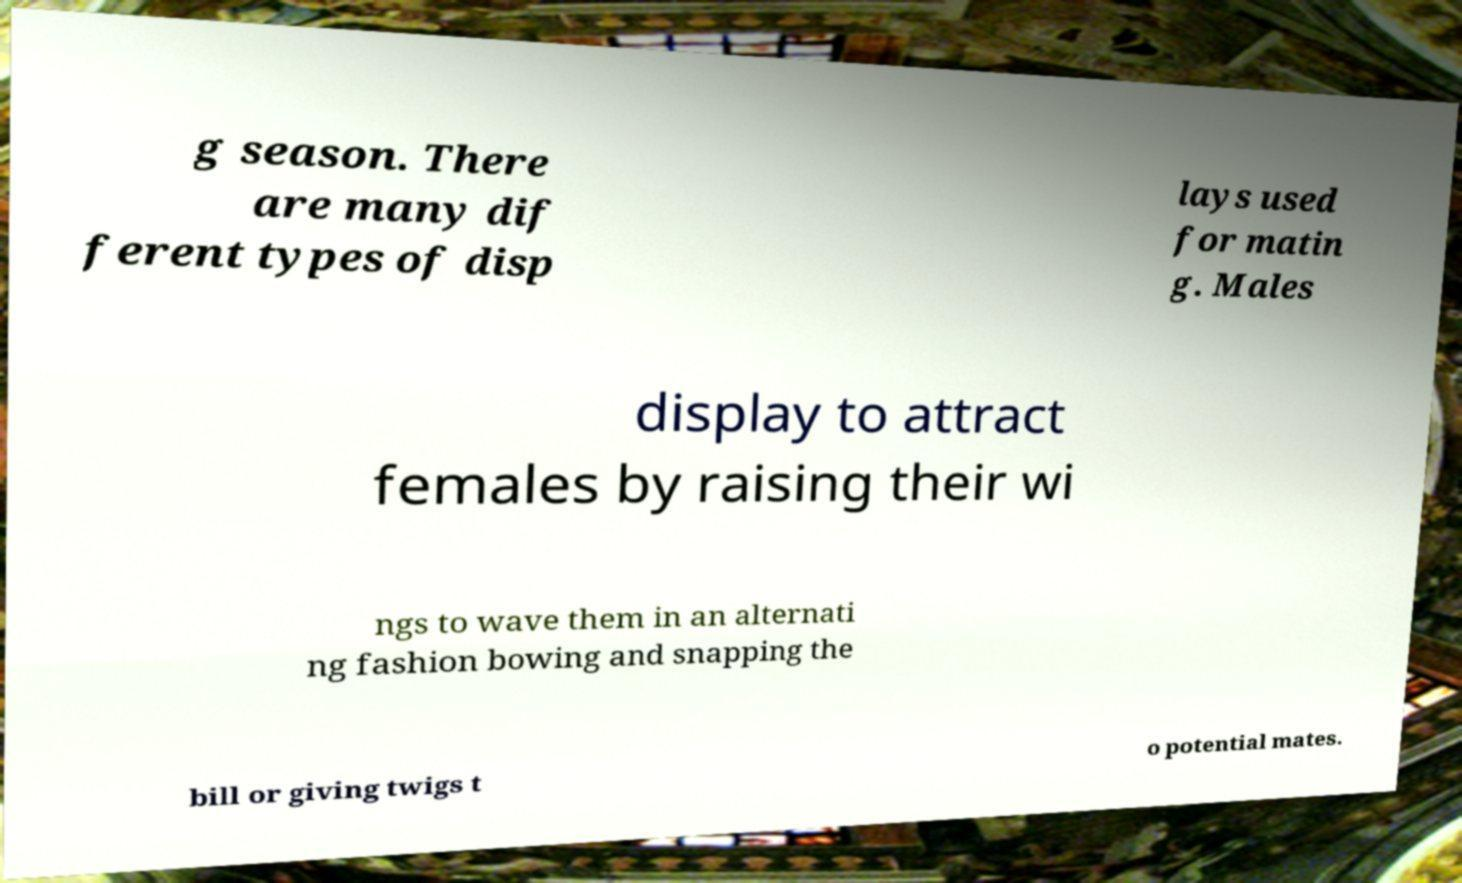Can you read and provide the text displayed in the image?This photo seems to have some interesting text. Can you extract and type it out for me? g season. There are many dif ferent types of disp lays used for matin g. Males display to attract females by raising their wi ngs to wave them in an alternati ng fashion bowing and snapping the bill or giving twigs t o potential mates. 